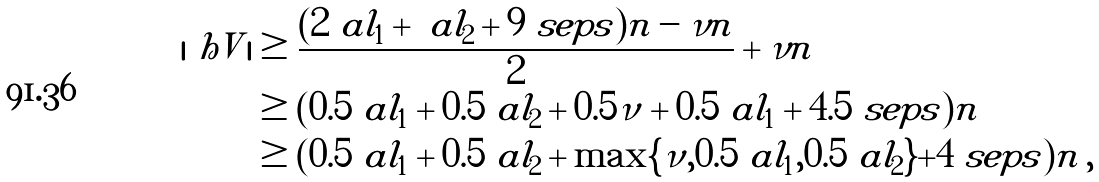Convert formula to latex. <formula><loc_0><loc_0><loc_500><loc_500>| \ h V | & \geq \frac { ( 2 \ a l _ { 1 } + \ a l _ { 2 } + 9 \ s e p s ) n - \nu n } { 2 } + \nu n \\ & \geq ( 0 . 5 \ a l _ { 1 } + 0 . 5 \ a l _ { 2 } + 0 . 5 \nu + 0 . 5 \ a l _ { 1 } + 4 . 5 \ s e p s ) n \\ & \geq ( 0 . 5 \ a l _ { 1 } + 0 . 5 \ a l _ { 2 } + \max \{ \nu , 0 . 5 \ a l _ { 1 } , 0 . 5 \ a l _ { 2 } \} + 4 \ s e p s ) n \, ,</formula> 